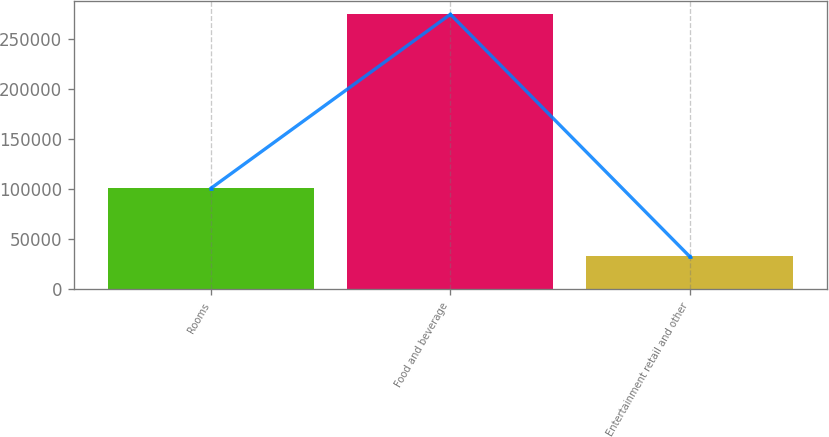Convert chart. <chart><loc_0><loc_0><loc_500><loc_500><bar_chart><fcel>Rooms<fcel>Food and beverage<fcel>Entertainment retail and other<nl><fcel>100968<fcel>274776<fcel>32705<nl></chart> 